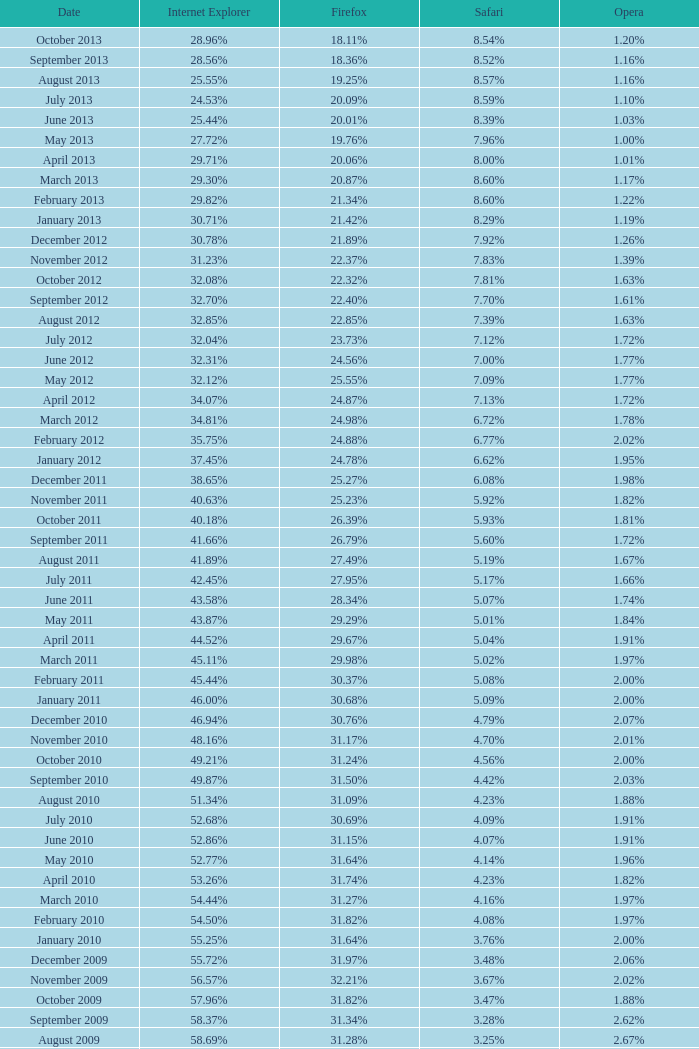What percentage of browsers were using Opera in November 2009? 2.02%. 